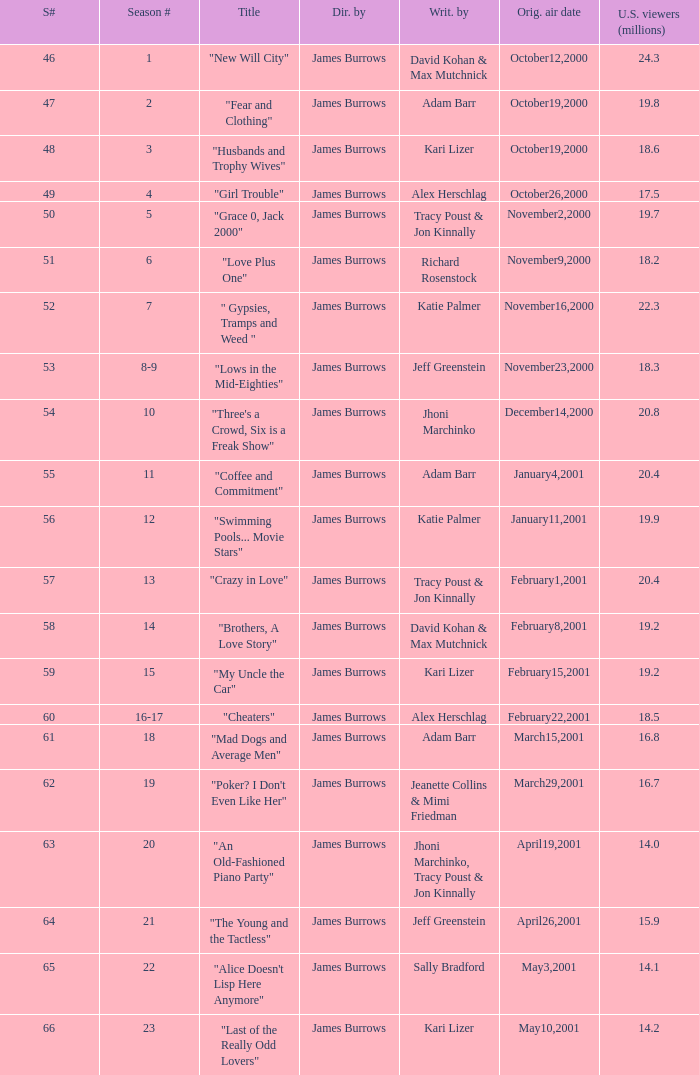Who wrote the episode titled "An Old-fashioned Piano Party"? Jhoni Marchinko, Tracy Poust & Jon Kinnally. 